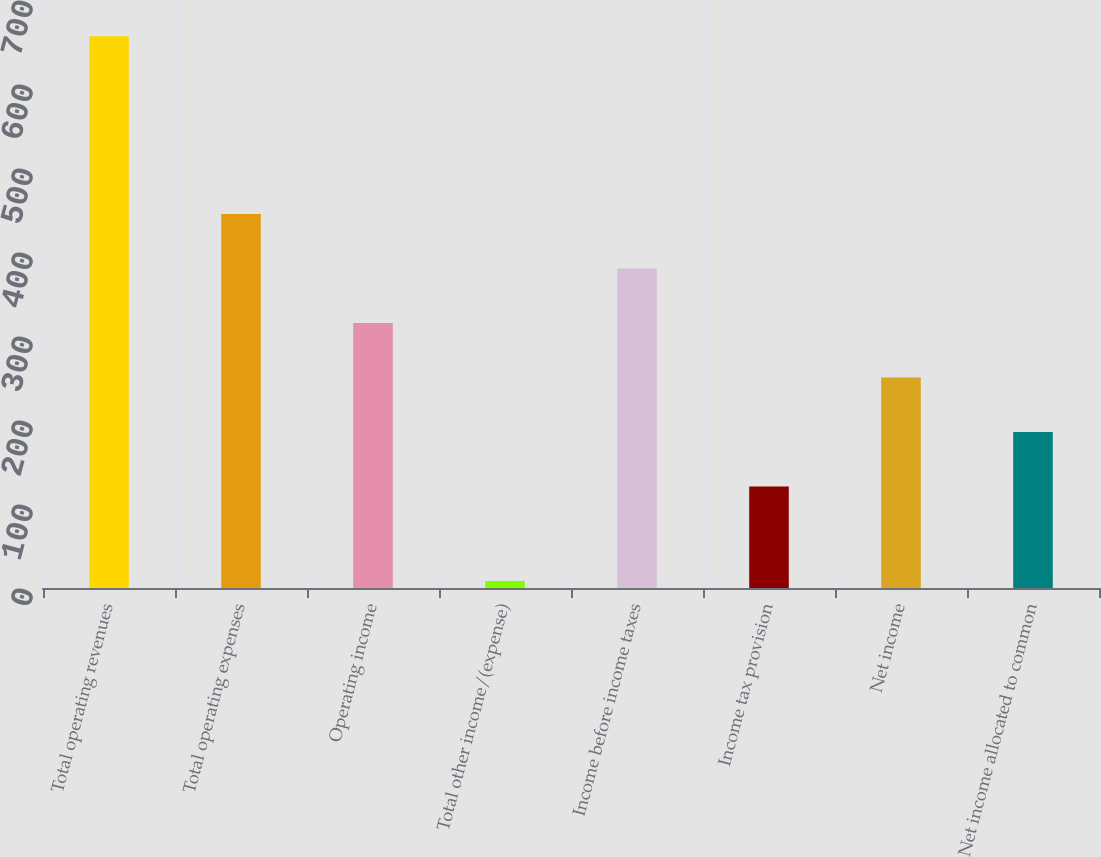Convert chart. <chart><loc_0><loc_0><loc_500><loc_500><bar_chart><fcel>Total operating revenues<fcel>Total operating expenses<fcel>Operating income<fcel>Total other income/(expense)<fcel>Income before income taxes<fcel>Income tax provision<fcel>Net income<fcel>Net income allocated to common<nl><fcel>656.9<fcel>445.15<fcel>315.45<fcel>8.4<fcel>380.3<fcel>120.9<fcel>250.6<fcel>185.75<nl></chart> 